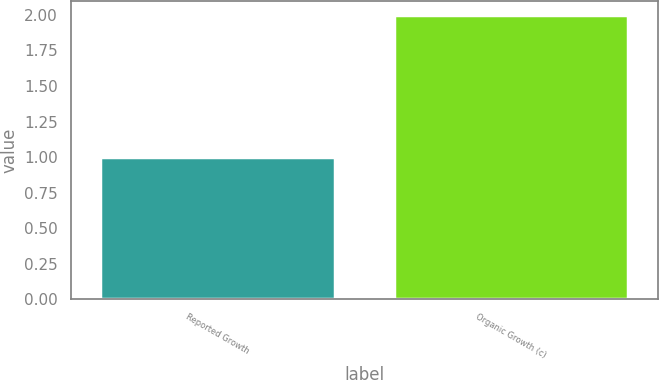Convert chart. <chart><loc_0><loc_0><loc_500><loc_500><bar_chart><fcel>Reported Growth<fcel>Organic Growth (c)<nl><fcel>1<fcel>2<nl></chart> 